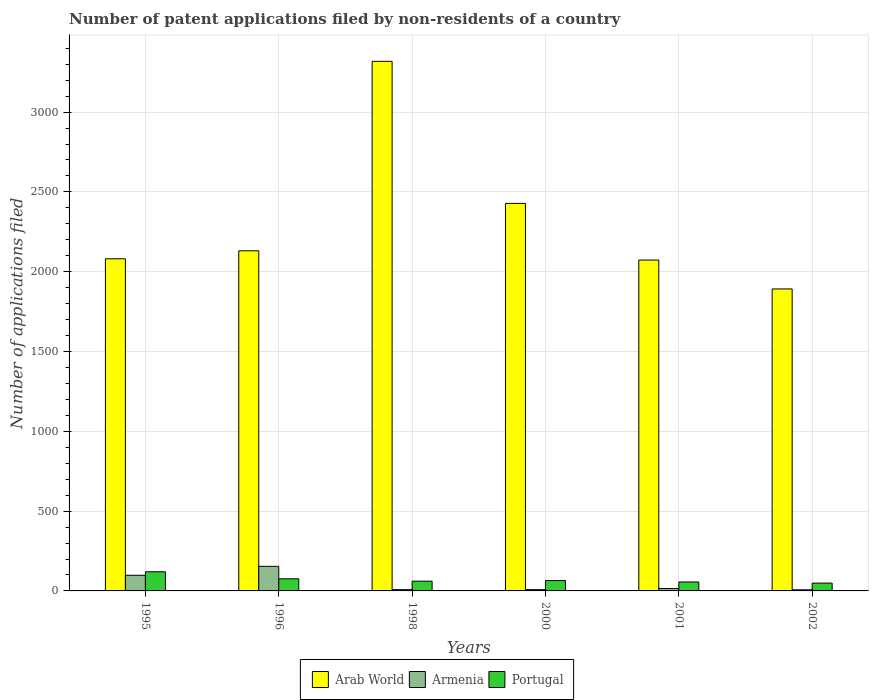How many different coloured bars are there?
Your response must be concise. 3. How many groups of bars are there?
Offer a very short reply. 6. Are the number of bars per tick equal to the number of legend labels?
Keep it short and to the point. Yes. What is the label of the 6th group of bars from the left?
Provide a short and direct response. 2002. What is the number of applications filed in Arab World in 2002?
Give a very brief answer. 1892. Across all years, what is the maximum number of applications filed in Portugal?
Ensure brevity in your answer.  120. In which year was the number of applications filed in Arab World maximum?
Your answer should be very brief. 1998. What is the total number of applications filed in Portugal in the graph?
Your answer should be compact. 427. What is the difference between the number of applications filed in Armenia in 1996 and that in 1998?
Provide a succinct answer. 146. What is the difference between the number of applications filed in Portugal in 2000 and the number of applications filed in Arab World in 2002?
Keep it short and to the point. -1827. What is the average number of applications filed in Arab World per year?
Your answer should be compact. 2320.5. In the year 1998, what is the difference between the number of applications filed in Armenia and number of applications filed in Portugal?
Give a very brief answer. -53. What is the ratio of the number of applications filed in Portugal in 1995 to that in 2002?
Ensure brevity in your answer.  2.45. Is the number of applications filed in Arab World in 1995 less than that in 2001?
Keep it short and to the point. No. Is the difference between the number of applications filed in Armenia in 2001 and 2002 greater than the difference between the number of applications filed in Portugal in 2001 and 2002?
Make the answer very short. Yes. What is the difference between the highest and the second highest number of applications filed in Portugal?
Ensure brevity in your answer.  44. What is the difference between the highest and the lowest number of applications filed in Armenia?
Your answer should be very brief. 147. In how many years, is the number of applications filed in Portugal greater than the average number of applications filed in Portugal taken over all years?
Offer a very short reply. 2. Is the sum of the number of applications filed in Arab World in 1995 and 1996 greater than the maximum number of applications filed in Armenia across all years?
Keep it short and to the point. Yes. What does the 3rd bar from the right in 1995 represents?
Your answer should be compact. Arab World. Is it the case that in every year, the sum of the number of applications filed in Armenia and number of applications filed in Arab World is greater than the number of applications filed in Portugal?
Your response must be concise. Yes. How many bars are there?
Provide a succinct answer. 18. How many years are there in the graph?
Your response must be concise. 6. Does the graph contain grids?
Make the answer very short. Yes. How many legend labels are there?
Your answer should be compact. 3. What is the title of the graph?
Offer a very short reply. Number of patent applications filed by non-residents of a country. Does "Liechtenstein" appear as one of the legend labels in the graph?
Offer a terse response. No. What is the label or title of the Y-axis?
Give a very brief answer. Number of applications filed. What is the Number of applications filed of Arab World in 1995?
Your answer should be very brief. 2081. What is the Number of applications filed of Armenia in 1995?
Provide a succinct answer. 98. What is the Number of applications filed of Portugal in 1995?
Offer a very short reply. 120. What is the Number of applications filed of Arab World in 1996?
Offer a very short reply. 2131. What is the Number of applications filed of Armenia in 1996?
Ensure brevity in your answer.  154. What is the Number of applications filed of Arab World in 1998?
Offer a very short reply. 3318. What is the Number of applications filed of Armenia in 1998?
Ensure brevity in your answer.  8. What is the Number of applications filed in Portugal in 1998?
Your answer should be very brief. 61. What is the Number of applications filed in Arab World in 2000?
Ensure brevity in your answer.  2428. What is the Number of applications filed in Armenia in 2000?
Provide a short and direct response. 8. What is the Number of applications filed of Arab World in 2001?
Give a very brief answer. 2073. What is the Number of applications filed in Armenia in 2001?
Offer a terse response. 15. What is the Number of applications filed of Arab World in 2002?
Ensure brevity in your answer.  1892. Across all years, what is the maximum Number of applications filed in Arab World?
Your response must be concise. 3318. Across all years, what is the maximum Number of applications filed of Armenia?
Give a very brief answer. 154. Across all years, what is the maximum Number of applications filed in Portugal?
Your answer should be very brief. 120. Across all years, what is the minimum Number of applications filed of Arab World?
Make the answer very short. 1892. What is the total Number of applications filed of Arab World in the graph?
Keep it short and to the point. 1.39e+04. What is the total Number of applications filed in Armenia in the graph?
Provide a short and direct response. 290. What is the total Number of applications filed in Portugal in the graph?
Your answer should be very brief. 427. What is the difference between the Number of applications filed of Arab World in 1995 and that in 1996?
Provide a succinct answer. -50. What is the difference between the Number of applications filed of Armenia in 1995 and that in 1996?
Provide a short and direct response. -56. What is the difference between the Number of applications filed of Portugal in 1995 and that in 1996?
Give a very brief answer. 44. What is the difference between the Number of applications filed of Arab World in 1995 and that in 1998?
Your answer should be very brief. -1237. What is the difference between the Number of applications filed in Armenia in 1995 and that in 1998?
Your answer should be very brief. 90. What is the difference between the Number of applications filed of Portugal in 1995 and that in 1998?
Your answer should be very brief. 59. What is the difference between the Number of applications filed in Arab World in 1995 and that in 2000?
Make the answer very short. -347. What is the difference between the Number of applications filed of Armenia in 1995 and that in 2001?
Your answer should be compact. 83. What is the difference between the Number of applications filed in Portugal in 1995 and that in 2001?
Give a very brief answer. 64. What is the difference between the Number of applications filed in Arab World in 1995 and that in 2002?
Give a very brief answer. 189. What is the difference between the Number of applications filed in Armenia in 1995 and that in 2002?
Provide a succinct answer. 91. What is the difference between the Number of applications filed in Arab World in 1996 and that in 1998?
Provide a short and direct response. -1187. What is the difference between the Number of applications filed in Armenia in 1996 and that in 1998?
Give a very brief answer. 146. What is the difference between the Number of applications filed in Portugal in 1996 and that in 1998?
Give a very brief answer. 15. What is the difference between the Number of applications filed in Arab World in 1996 and that in 2000?
Your answer should be compact. -297. What is the difference between the Number of applications filed in Armenia in 1996 and that in 2000?
Your answer should be compact. 146. What is the difference between the Number of applications filed in Portugal in 1996 and that in 2000?
Make the answer very short. 11. What is the difference between the Number of applications filed of Arab World in 1996 and that in 2001?
Ensure brevity in your answer.  58. What is the difference between the Number of applications filed of Armenia in 1996 and that in 2001?
Provide a succinct answer. 139. What is the difference between the Number of applications filed of Portugal in 1996 and that in 2001?
Provide a succinct answer. 20. What is the difference between the Number of applications filed in Arab World in 1996 and that in 2002?
Provide a short and direct response. 239. What is the difference between the Number of applications filed of Armenia in 1996 and that in 2002?
Keep it short and to the point. 147. What is the difference between the Number of applications filed in Portugal in 1996 and that in 2002?
Offer a terse response. 27. What is the difference between the Number of applications filed of Arab World in 1998 and that in 2000?
Your answer should be compact. 890. What is the difference between the Number of applications filed in Portugal in 1998 and that in 2000?
Ensure brevity in your answer.  -4. What is the difference between the Number of applications filed of Arab World in 1998 and that in 2001?
Keep it short and to the point. 1245. What is the difference between the Number of applications filed in Portugal in 1998 and that in 2001?
Provide a succinct answer. 5. What is the difference between the Number of applications filed of Arab World in 1998 and that in 2002?
Your answer should be compact. 1426. What is the difference between the Number of applications filed in Armenia in 1998 and that in 2002?
Your answer should be compact. 1. What is the difference between the Number of applications filed of Portugal in 1998 and that in 2002?
Your response must be concise. 12. What is the difference between the Number of applications filed in Arab World in 2000 and that in 2001?
Keep it short and to the point. 355. What is the difference between the Number of applications filed of Armenia in 2000 and that in 2001?
Provide a succinct answer. -7. What is the difference between the Number of applications filed in Portugal in 2000 and that in 2001?
Your answer should be very brief. 9. What is the difference between the Number of applications filed of Arab World in 2000 and that in 2002?
Offer a very short reply. 536. What is the difference between the Number of applications filed of Armenia in 2000 and that in 2002?
Offer a very short reply. 1. What is the difference between the Number of applications filed in Arab World in 2001 and that in 2002?
Provide a short and direct response. 181. What is the difference between the Number of applications filed of Armenia in 2001 and that in 2002?
Provide a short and direct response. 8. What is the difference between the Number of applications filed in Arab World in 1995 and the Number of applications filed in Armenia in 1996?
Ensure brevity in your answer.  1927. What is the difference between the Number of applications filed in Arab World in 1995 and the Number of applications filed in Portugal in 1996?
Offer a very short reply. 2005. What is the difference between the Number of applications filed in Armenia in 1995 and the Number of applications filed in Portugal in 1996?
Offer a terse response. 22. What is the difference between the Number of applications filed in Arab World in 1995 and the Number of applications filed in Armenia in 1998?
Your answer should be very brief. 2073. What is the difference between the Number of applications filed of Arab World in 1995 and the Number of applications filed of Portugal in 1998?
Offer a terse response. 2020. What is the difference between the Number of applications filed in Arab World in 1995 and the Number of applications filed in Armenia in 2000?
Make the answer very short. 2073. What is the difference between the Number of applications filed in Arab World in 1995 and the Number of applications filed in Portugal in 2000?
Offer a very short reply. 2016. What is the difference between the Number of applications filed in Armenia in 1995 and the Number of applications filed in Portugal in 2000?
Offer a very short reply. 33. What is the difference between the Number of applications filed of Arab World in 1995 and the Number of applications filed of Armenia in 2001?
Ensure brevity in your answer.  2066. What is the difference between the Number of applications filed in Arab World in 1995 and the Number of applications filed in Portugal in 2001?
Offer a very short reply. 2025. What is the difference between the Number of applications filed in Arab World in 1995 and the Number of applications filed in Armenia in 2002?
Your response must be concise. 2074. What is the difference between the Number of applications filed of Arab World in 1995 and the Number of applications filed of Portugal in 2002?
Your answer should be compact. 2032. What is the difference between the Number of applications filed of Armenia in 1995 and the Number of applications filed of Portugal in 2002?
Give a very brief answer. 49. What is the difference between the Number of applications filed of Arab World in 1996 and the Number of applications filed of Armenia in 1998?
Offer a very short reply. 2123. What is the difference between the Number of applications filed of Arab World in 1996 and the Number of applications filed of Portugal in 1998?
Provide a short and direct response. 2070. What is the difference between the Number of applications filed of Armenia in 1996 and the Number of applications filed of Portugal in 1998?
Offer a terse response. 93. What is the difference between the Number of applications filed in Arab World in 1996 and the Number of applications filed in Armenia in 2000?
Offer a terse response. 2123. What is the difference between the Number of applications filed in Arab World in 1996 and the Number of applications filed in Portugal in 2000?
Provide a short and direct response. 2066. What is the difference between the Number of applications filed in Armenia in 1996 and the Number of applications filed in Portugal in 2000?
Give a very brief answer. 89. What is the difference between the Number of applications filed of Arab World in 1996 and the Number of applications filed of Armenia in 2001?
Make the answer very short. 2116. What is the difference between the Number of applications filed of Arab World in 1996 and the Number of applications filed of Portugal in 2001?
Offer a terse response. 2075. What is the difference between the Number of applications filed of Arab World in 1996 and the Number of applications filed of Armenia in 2002?
Offer a terse response. 2124. What is the difference between the Number of applications filed in Arab World in 1996 and the Number of applications filed in Portugal in 2002?
Give a very brief answer. 2082. What is the difference between the Number of applications filed of Armenia in 1996 and the Number of applications filed of Portugal in 2002?
Keep it short and to the point. 105. What is the difference between the Number of applications filed of Arab World in 1998 and the Number of applications filed of Armenia in 2000?
Offer a very short reply. 3310. What is the difference between the Number of applications filed in Arab World in 1998 and the Number of applications filed in Portugal in 2000?
Provide a short and direct response. 3253. What is the difference between the Number of applications filed of Armenia in 1998 and the Number of applications filed of Portugal in 2000?
Ensure brevity in your answer.  -57. What is the difference between the Number of applications filed of Arab World in 1998 and the Number of applications filed of Armenia in 2001?
Your answer should be very brief. 3303. What is the difference between the Number of applications filed of Arab World in 1998 and the Number of applications filed of Portugal in 2001?
Give a very brief answer. 3262. What is the difference between the Number of applications filed in Armenia in 1998 and the Number of applications filed in Portugal in 2001?
Keep it short and to the point. -48. What is the difference between the Number of applications filed of Arab World in 1998 and the Number of applications filed of Armenia in 2002?
Keep it short and to the point. 3311. What is the difference between the Number of applications filed in Arab World in 1998 and the Number of applications filed in Portugal in 2002?
Ensure brevity in your answer.  3269. What is the difference between the Number of applications filed of Armenia in 1998 and the Number of applications filed of Portugal in 2002?
Provide a short and direct response. -41. What is the difference between the Number of applications filed in Arab World in 2000 and the Number of applications filed in Armenia in 2001?
Offer a terse response. 2413. What is the difference between the Number of applications filed of Arab World in 2000 and the Number of applications filed of Portugal in 2001?
Offer a very short reply. 2372. What is the difference between the Number of applications filed of Armenia in 2000 and the Number of applications filed of Portugal in 2001?
Your answer should be compact. -48. What is the difference between the Number of applications filed of Arab World in 2000 and the Number of applications filed of Armenia in 2002?
Ensure brevity in your answer.  2421. What is the difference between the Number of applications filed in Arab World in 2000 and the Number of applications filed in Portugal in 2002?
Offer a terse response. 2379. What is the difference between the Number of applications filed of Armenia in 2000 and the Number of applications filed of Portugal in 2002?
Ensure brevity in your answer.  -41. What is the difference between the Number of applications filed of Arab World in 2001 and the Number of applications filed of Armenia in 2002?
Provide a succinct answer. 2066. What is the difference between the Number of applications filed of Arab World in 2001 and the Number of applications filed of Portugal in 2002?
Ensure brevity in your answer.  2024. What is the difference between the Number of applications filed in Armenia in 2001 and the Number of applications filed in Portugal in 2002?
Give a very brief answer. -34. What is the average Number of applications filed of Arab World per year?
Provide a short and direct response. 2320.5. What is the average Number of applications filed in Armenia per year?
Offer a very short reply. 48.33. What is the average Number of applications filed in Portugal per year?
Your answer should be very brief. 71.17. In the year 1995, what is the difference between the Number of applications filed in Arab World and Number of applications filed in Armenia?
Provide a short and direct response. 1983. In the year 1995, what is the difference between the Number of applications filed in Arab World and Number of applications filed in Portugal?
Ensure brevity in your answer.  1961. In the year 1996, what is the difference between the Number of applications filed of Arab World and Number of applications filed of Armenia?
Keep it short and to the point. 1977. In the year 1996, what is the difference between the Number of applications filed in Arab World and Number of applications filed in Portugal?
Offer a very short reply. 2055. In the year 1998, what is the difference between the Number of applications filed of Arab World and Number of applications filed of Armenia?
Your response must be concise. 3310. In the year 1998, what is the difference between the Number of applications filed in Arab World and Number of applications filed in Portugal?
Your response must be concise. 3257. In the year 1998, what is the difference between the Number of applications filed in Armenia and Number of applications filed in Portugal?
Provide a short and direct response. -53. In the year 2000, what is the difference between the Number of applications filed in Arab World and Number of applications filed in Armenia?
Your answer should be very brief. 2420. In the year 2000, what is the difference between the Number of applications filed of Arab World and Number of applications filed of Portugal?
Offer a terse response. 2363. In the year 2000, what is the difference between the Number of applications filed of Armenia and Number of applications filed of Portugal?
Provide a short and direct response. -57. In the year 2001, what is the difference between the Number of applications filed in Arab World and Number of applications filed in Armenia?
Ensure brevity in your answer.  2058. In the year 2001, what is the difference between the Number of applications filed in Arab World and Number of applications filed in Portugal?
Provide a short and direct response. 2017. In the year 2001, what is the difference between the Number of applications filed in Armenia and Number of applications filed in Portugal?
Provide a succinct answer. -41. In the year 2002, what is the difference between the Number of applications filed of Arab World and Number of applications filed of Armenia?
Ensure brevity in your answer.  1885. In the year 2002, what is the difference between the Number of applications filed of Arab World and Number of applications filed of Portugal?
Give a very brief answer. 1843. In the year 2002, what is the difference between the Number of applications filed in Armenia and Number of applications filed in Portugal?
Provide a succinct answer. -42. What is the ratio of the Number of applications filed of Arab World in 1995 to that in 1996?
Offer a very short reply. 0.98. What is the ratio of the Number of applications filed of Armenia in 1995 to that in 1996?
Make the answer very short. 0.64. What is the ratio of the Number of applications filed in Portugal in 1995 to that in 1996?
Provide a succinct answer. 1.58. What is the ratio of the Number of applications filed of Arab World in 1995 to that in 1998?
Keep it short and to the point. 0.63. What is the ratio of the Number of applications filed of Armenia in 1995 to that in 1998?
Offer a terse response. 12.25. What is the ratio of the Number of applications filed of Portugal in 1995 to that in 1998?
Offer a terse response. 1.97. What is the ratio of the Number of applications filed of Armenia in 1995 to that in 2000?
Offer a very short reply. 12.25. What is the ratio of the Number of applications filed in Portugal in 1995 to that in 2000?
Your response must be concise. 1.85. What is the ratio of the Number of applications filed in Arab World in 1995 to that in 2001?
Offer a terse response. 1. What is the ratio of the Number of applications filed in Armenia in 1995 to that in 2001?
Your response must be concise. 6.53. What is the ratio of the Number of applications filed of Portugal in 1995 to that in 2001?
Ensure brevity in your answer.  2.14. What is the ratio of the Number of applications filed in Arab World in 1995 to that in 2002?
Your response must be concise. 1.1. What is the ratio of the Number of applications filed of Armenia in 1995 to that in 2002?
Give a very brief answer. 14. What is the ratio of the Number of applications filed of Portugal in 1995 to that in 2002?
Your answer should be compact. 2.45. What is the ratio of the Number of applications filed in Arab World in 1996 to that in 1998?
Your answer should be very brief. 0.64. What is the ratio of the Number of applications filed in Armenia in 1996 to that in 1998?
Your answer should be compact. 19.25. What is the ratio of the Number of applications filed in Portugal in 1996 to that in 1998?
Your response must be concise. 1.25. What is the ratio of the Number of applications filed of Arab World in 1996 to that in 2000?
Offer a terse response. 0.88. What is the ratio of the Number of applications filed in Armenia in 1996 to that in 2000?
Your answer should be very brief. 19.25. What is the ratio of the Number of applications filed of Portugal in 1996 to that in 2000?
Make the answer very short. 1.17. What is the ratio of the Number of applications filed in Arab World in 1996 to that in 2001?
Give a very brief answer. 1.03. What is the ratio of the Number of applications filed of Armenia in 1996 to that in 2001?
Your response must be concise. 10.27. What is the ratio of the Number of applications filed in Portugal in 1996 to that in 2001?
Keep it short and to the point. 1.36. What is the ratio of the Number of applications filed of Arab World in 1996 to that in 2002?
Keep it short and to the point. 1.13. What is the ratio of the Number of applications filed of Portugal in 1996 to that in 2002?
Give a very brief answer. 1.55. What is the ratio of the Number of applications filed in Arab World in 1998 to that in 2000?
Provide a short and direct response. 1.37. What is the ratio of the Number of applications filed in Portugal in 1998 to that in 2000?
Ensure brevity in your answer.  0.94. What is the ratio of the Number of applications filed in Arab World in 1998 to that in 2001?
Give a very brief answer. 1.6. What is the ratio of the Number of applications filed in Armenia in 1998 to that in 2001?
Your answer should be compact. 0.53. What is the ratio of the Number of applications filed of Portugal in 1998 to that in 2001?
Offer a very short reply. 1.09. What is the ratio of the Number of applications filed in Arab World in 1998 to that in 2002?
Offer a terse response. 1.75. What is the ratio of the Number of applications filed in Portugal in 1998 to that in 2002?
Ensure brevity in your answer.  1.24. What is the ratio of the Number of applications filed in Arab World in 2000 to that in 2001?
Your response must be concise. 1.17. What is the ratio of the Number of applications filed of Armenia in 2000 to that in 2001?
Give a very brief answer. 0.53. What is the ratio of the Number of applications filed in Portugal in 2000 to that in 2001?
Make the answer very short. 1.16. What is the ratio of the Number of applications filed in Arab World in 2000 to that in 2002?
Make the answer very short. 1.28. What is the ratio of the Number of applications filed of Armenia in 2000 to that in 2002?
Make the answer very short. 1.14. What is the ratio of the Number of applications filed in Portugal in 2000 to that in 2002?
Ensure brevity in your answer.  1.33. What is the ratio of the Number of applications filed of Arab World in 2001 to that in 2002?
Your answer should be compact. 1.1. What is the ratio of the Number of applications filed in Armenia in 2001 to that in 2002?
Ensure brevity in your answer.  2.14. What is the difference between the highest and the second highest Number of applications filed of Arab World?
Offer a very short reply. 890. What is the difference between the highest and the second highest Number of applications filed in Armenia?
Give a very brief answer. 56. What is the difference between the highest and the lowest Number of applications filed of Arab World?
Give a very brief answer. 1426. What is the difference between the highest and the lowest Number of applications filed in Armenia?
Ensure brevity in your answer.  147. What is the difference between the highest and the lowest Number of applications filed in Portugal?
Offer a terse response. 71. 